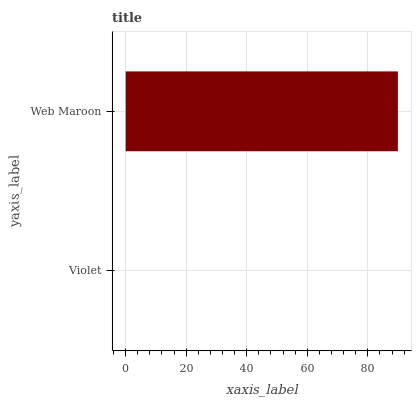Is Violet the minimum?
Answer yes or no. Yes. Is Web Maroon the maximum?
Answer yes or no. Yes. Is Web Maroon the minimum?
Answer yes or no. No. Is Web Maroon greater than Violet?
Answer yes or no. Yes. Is Violet less than Web Maroon?
Answer yes or no. Yes. Is Violet greater than Web Maroon?
Answer yes or no. No. Is Web Maroon less than Violet?
Answer yes or no. No. Is Web Maroon the high median?
Answer yes or no. Yes. Is Violet the low median?
Answer yes or no. Yes. Is Violet the high median?
Answer yes or no. No. Is Web Maroon the low median?
Answer yes or no. No. 